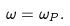<formula> <loc_0><loc_0><loc_500><loc_500>\omega = \omega _ { P } .</formula> 